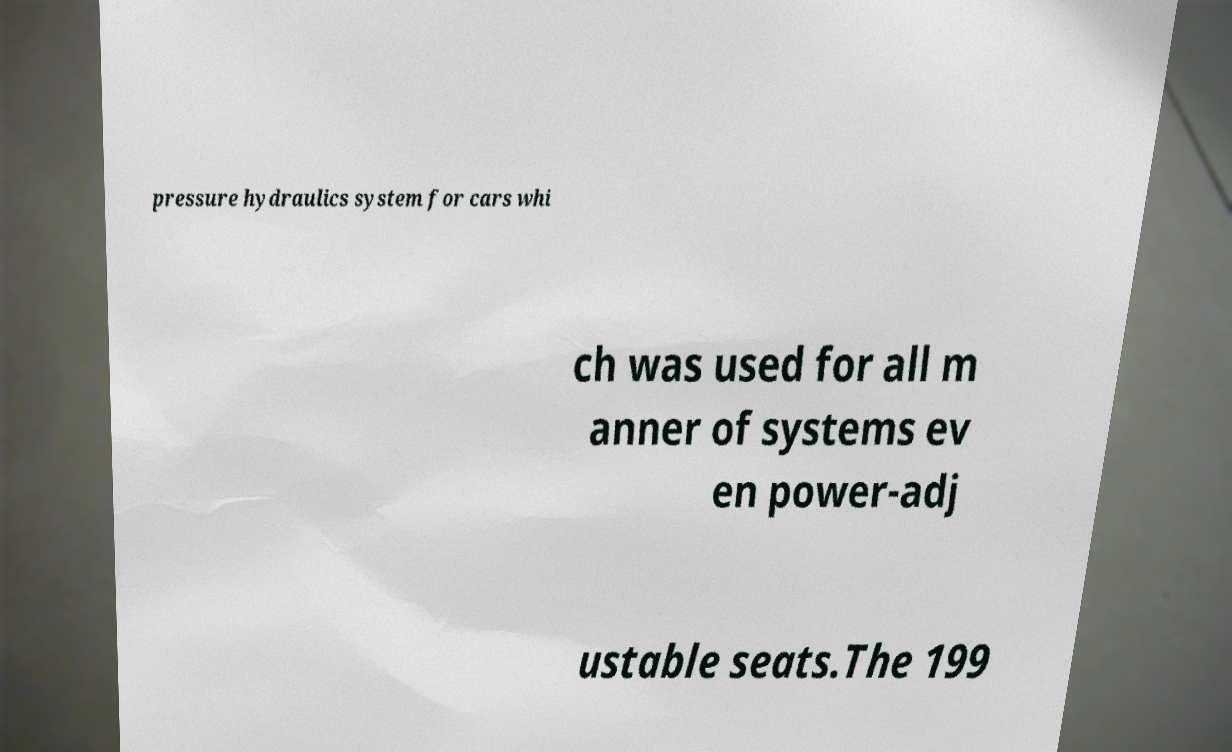What messages or text are displayed in this image? I need them in a readable, typed format. pressure hydraulics system for cars whi ch was used for all m anner of systems ev en power-adj ustable seats.The 199 